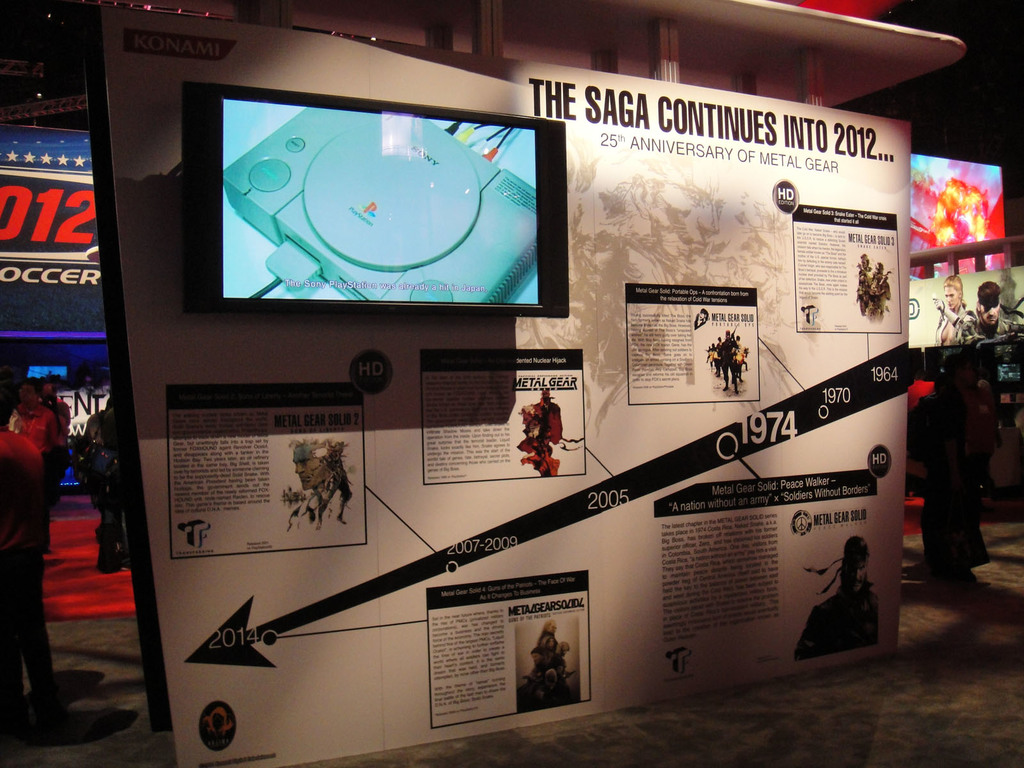Provide a one-sentence caption for the provided image.
Reference OCR token: KONAMI, THE, SAGA, CONTINUES, RSARY, OF, METAL, 25Th, ANNIVE, INTO, GEAR, 2012..., 012, OCCER, TheSon, ayStfor, OED, METALREABIUE, ETALGEAR, 1964, EN, 1970, 01974, 2005, MetalGe, Anation, T, CEARSILR, 2007-2009, ETMEEARSO/D, 2014 A timeline display celebrates 25 years of Metal Gear. 